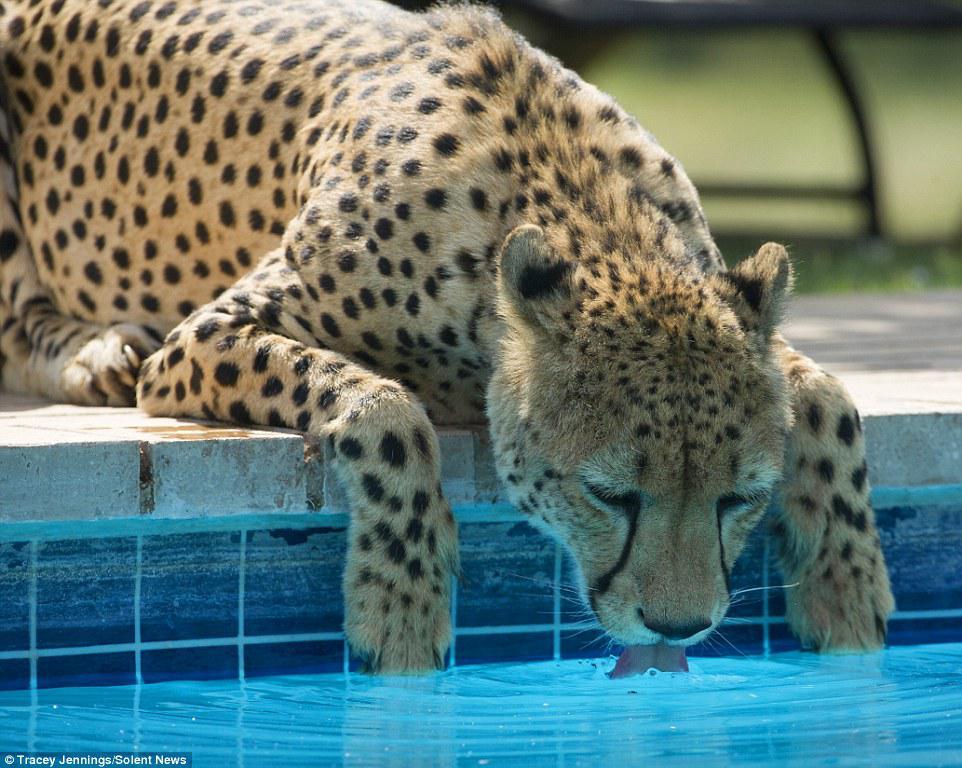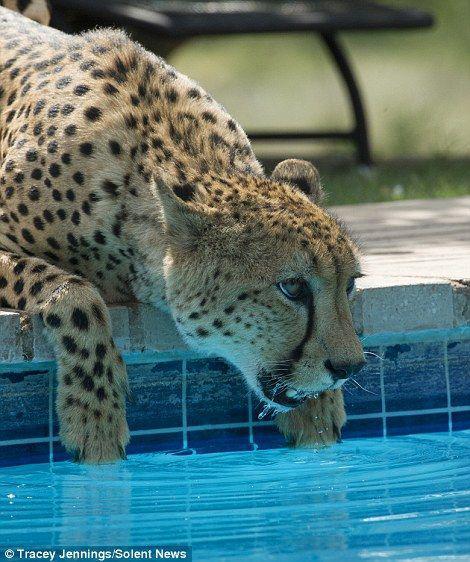The first image is the image on the left, the second image is the image on the right. For the images shown, is this caption "There is a leopard looking into a swimming pool in each image." true? Answer yes or no. Yes. The first image is the image on the left, the second image is the image on the right. Evaluate the accuracy of this statement regarding the images: "Each image shows at least one spotted wild cat leaning to drink out of a manmade swimming pool.". Is it true? Answer yes or no. Yes. 